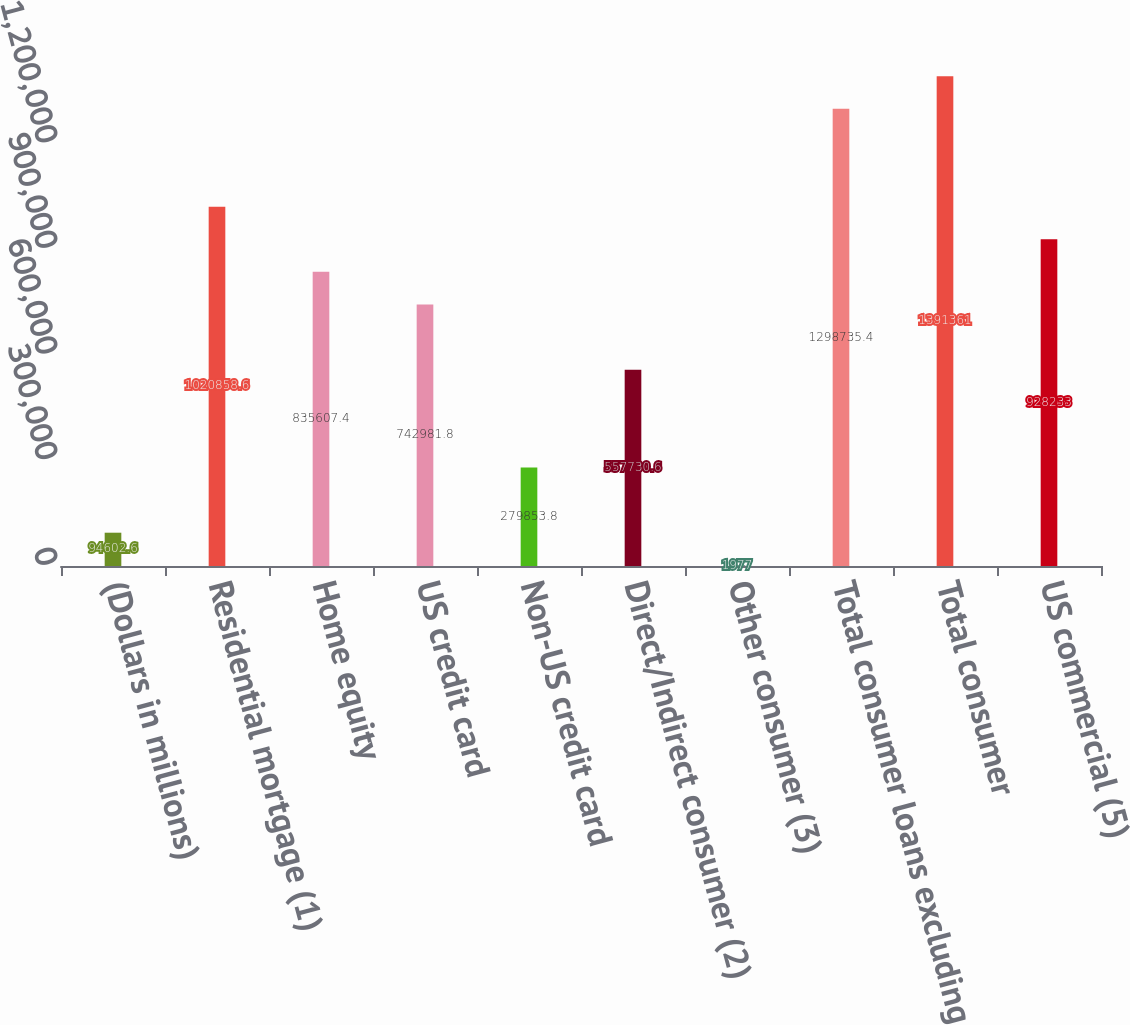Convert chart to OTSL. <chart><loc_0><loc_0><loc_500><loc_500><bar_chart><fcel>(Dollars in millions)<fcel>Residential mortgage (1)<fcel>Home equity<fcel>US credit card<fcel>Non-US credit card<fcel>Direct/Indirect consumer (2)<fcel>Other consumer (3)<fcel>Total consumer loans excluding<fcel>Total consumer<fcel>US commercial (5)<nl><fcel>94602.6<fcel>1.02086e+06<fcel>835607<fcel>742982<fcel>279854<fcel>557731<fcel>1977<fcel>1.29874e+06<fcel>1.39136e+06<fcel>928233<nl></chart> 